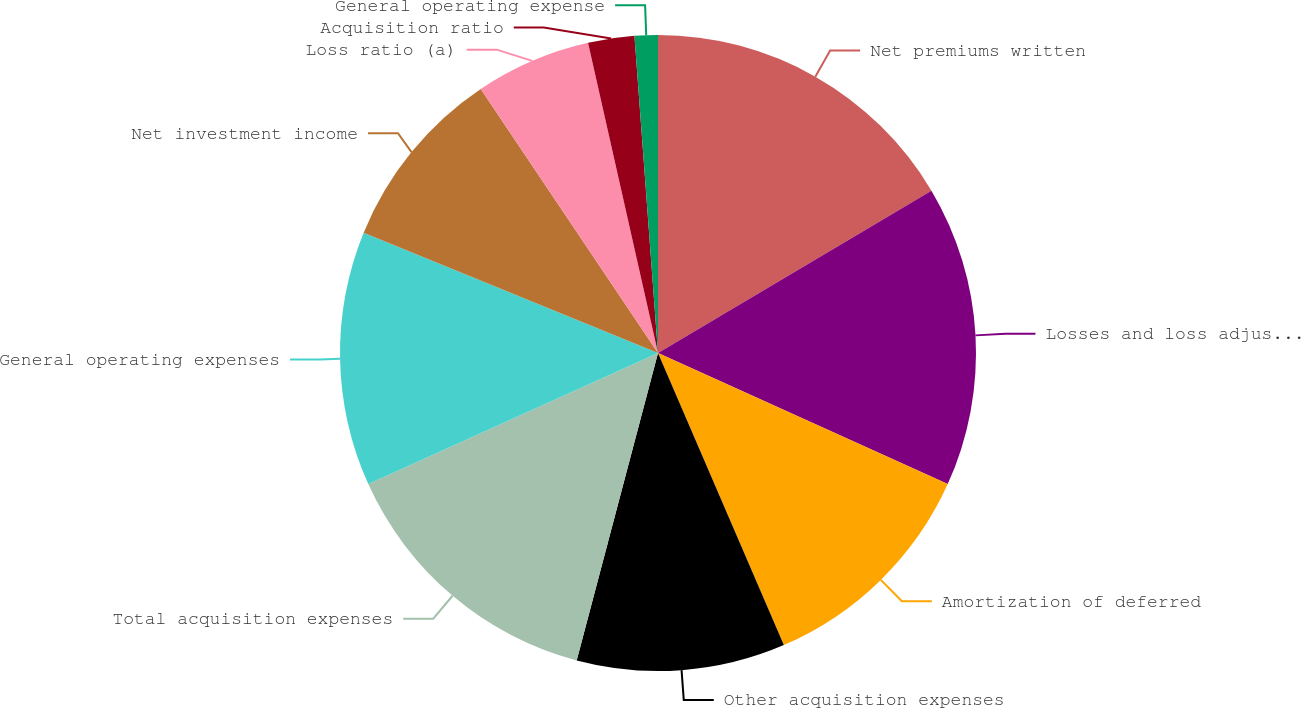Convert chart to OTSL. <chart><loc_0><loc_0><loc_500><loc_500><pie_chart><fcel>Net premiums written<fcel>Losses and loss adjustment<fcel>Amortization of deferred<fcel>Other acquisition expenses<fcel>Total acquisition expenses<fcel>General operating expenses<fcel>Net investment income<fcel>Loss ratio (a)<fcel>Acquisition ratio<fcel>General operating expense<nl><fcel>16.47%<fcel>15.29%<fcel>11.76%<fcel>10.59%<fcel>14.12%<fcel>12.94%<fcel>9.41%<fcel>5.88%<fcel>2.35%<fcel>1.18%<nl></chart> 